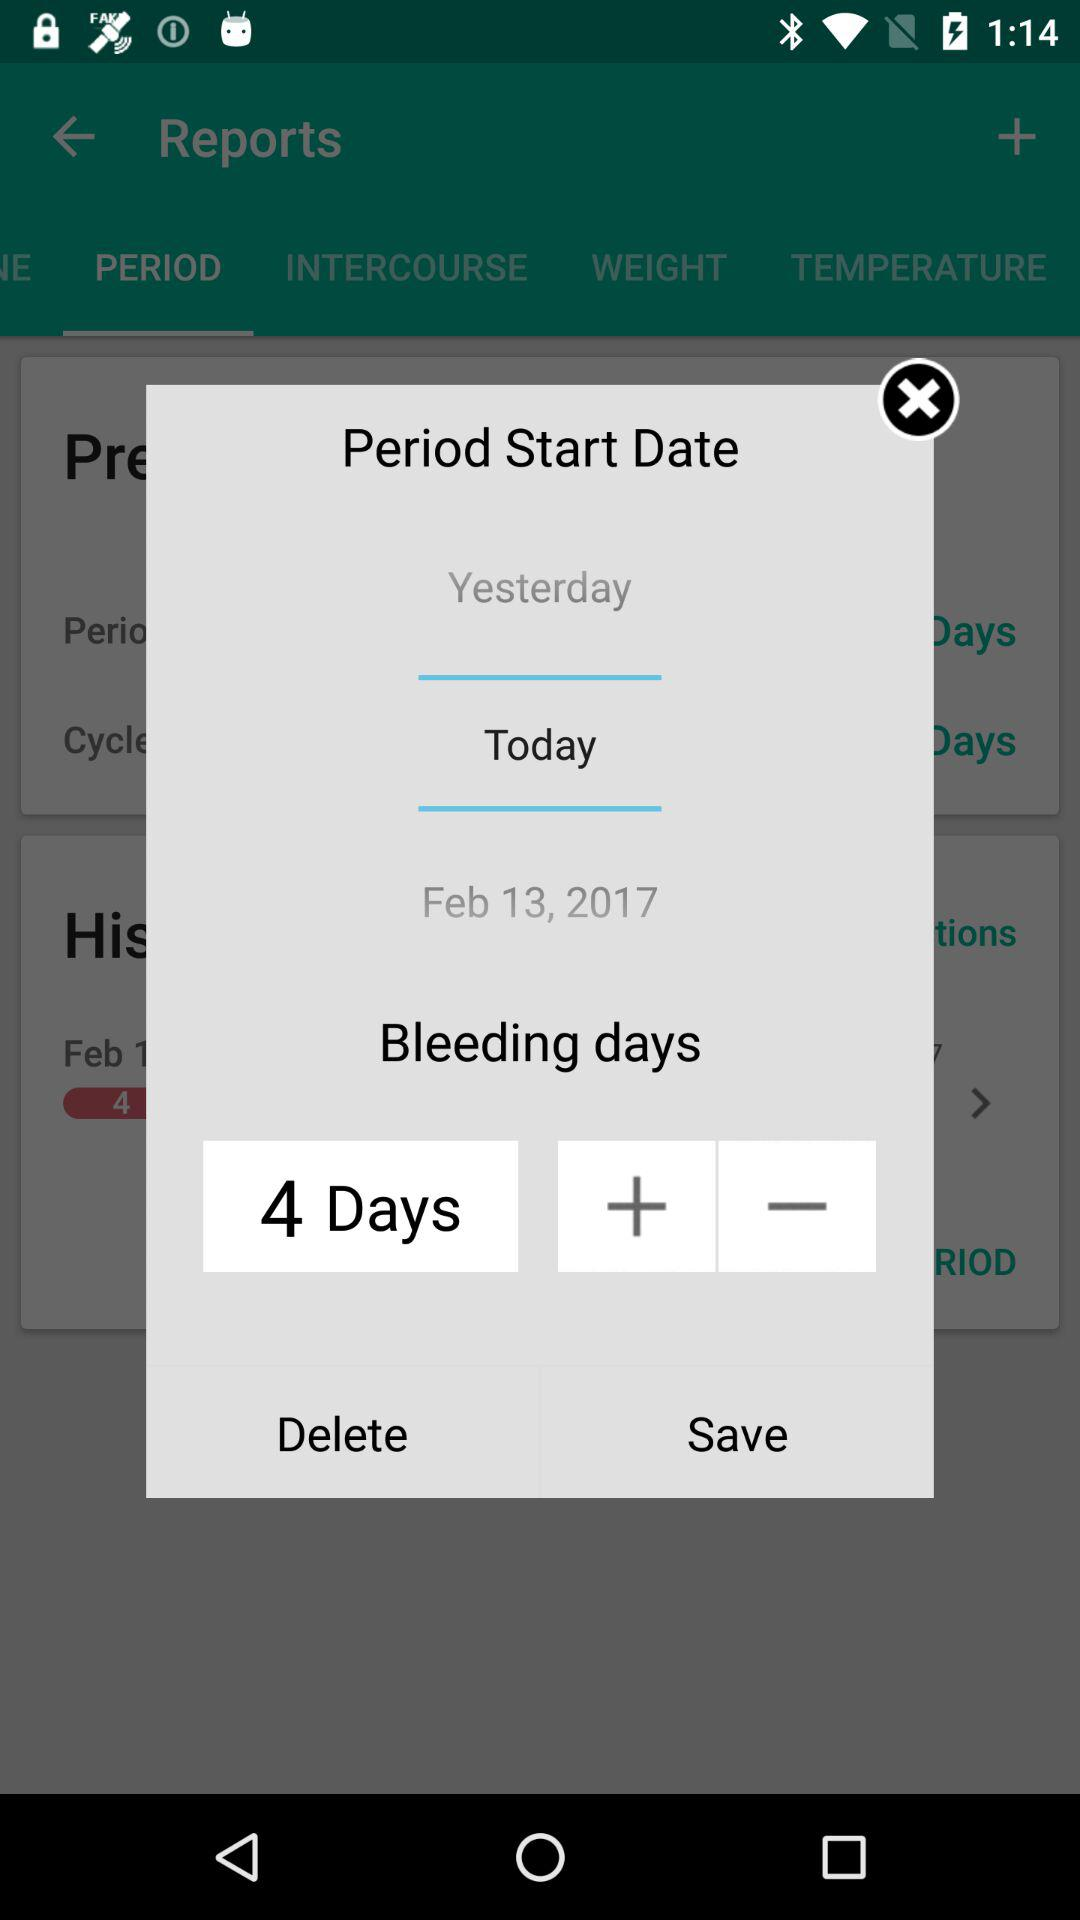How many "Bleeding days" are there? There are 4 "Bleeding days". 